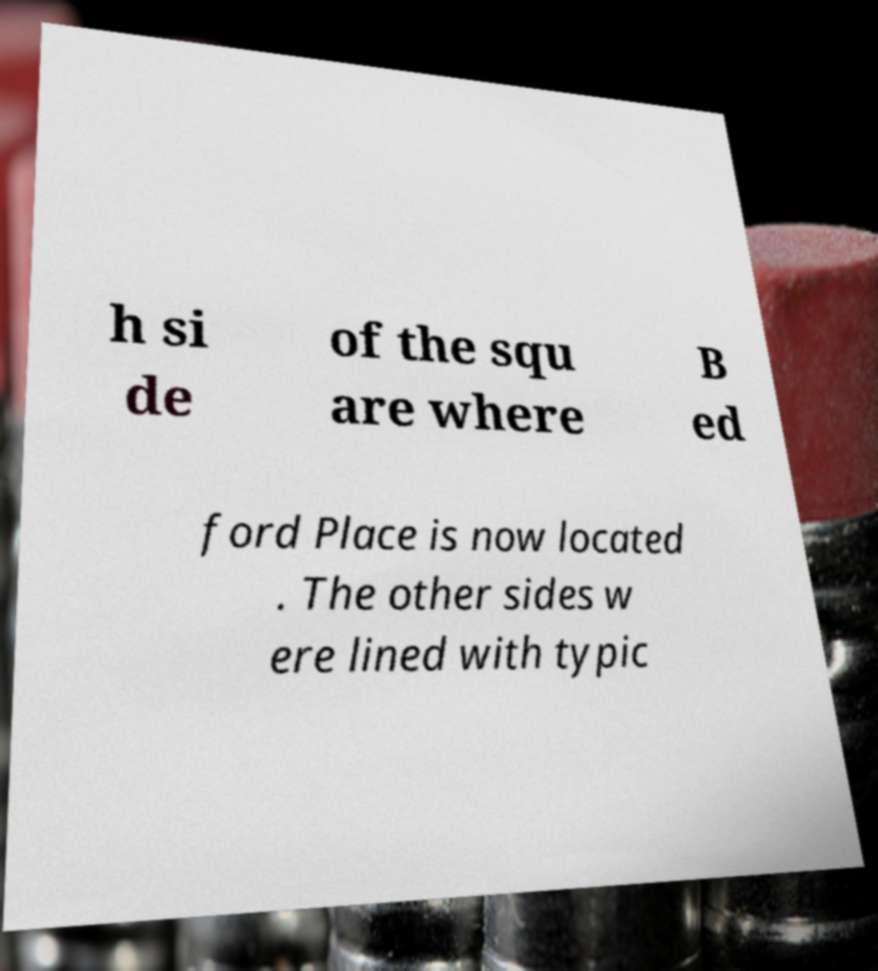Can you read and provide the text displayed in the image?This photo seems to have some interesting text. Can you extract and type it out for me? h si de of the squ are where B ed ford Place is now located . The other sides w ere lined with typic 